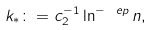Convert formula to latex. <formula><loc_0><loc_0><loc_500><loc_500>k _ { * } \colon = c _ { 2 } ^ { - 1 } \ln ^ { - \ e p } n ,</formula> 